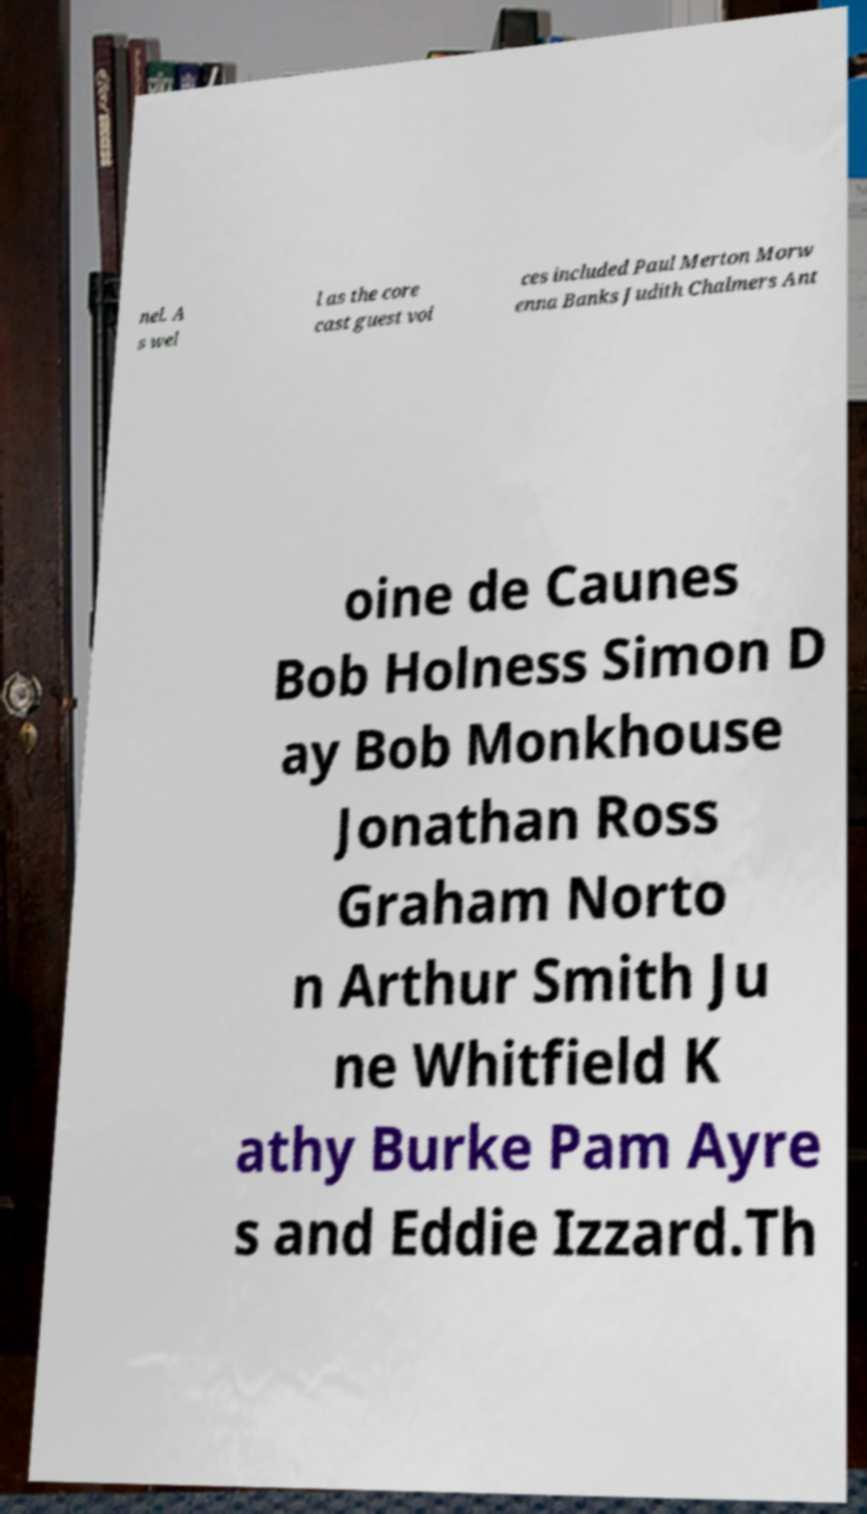There's text embedded in this image that I need extracted. Can you transcribe it verbatim? nel. A s wel l as the core cast guest voi ces included Paul Merton Morw enna Banks Judith Chalmers Ant oine de Caunes Bob Holness Simon D ay Bob Monkhouse Jonathan Ross Graham Norto n Arthur Smith Ju ne Whitfield K athy Burke Pam Ayre s and Eddie Izzard.Th 